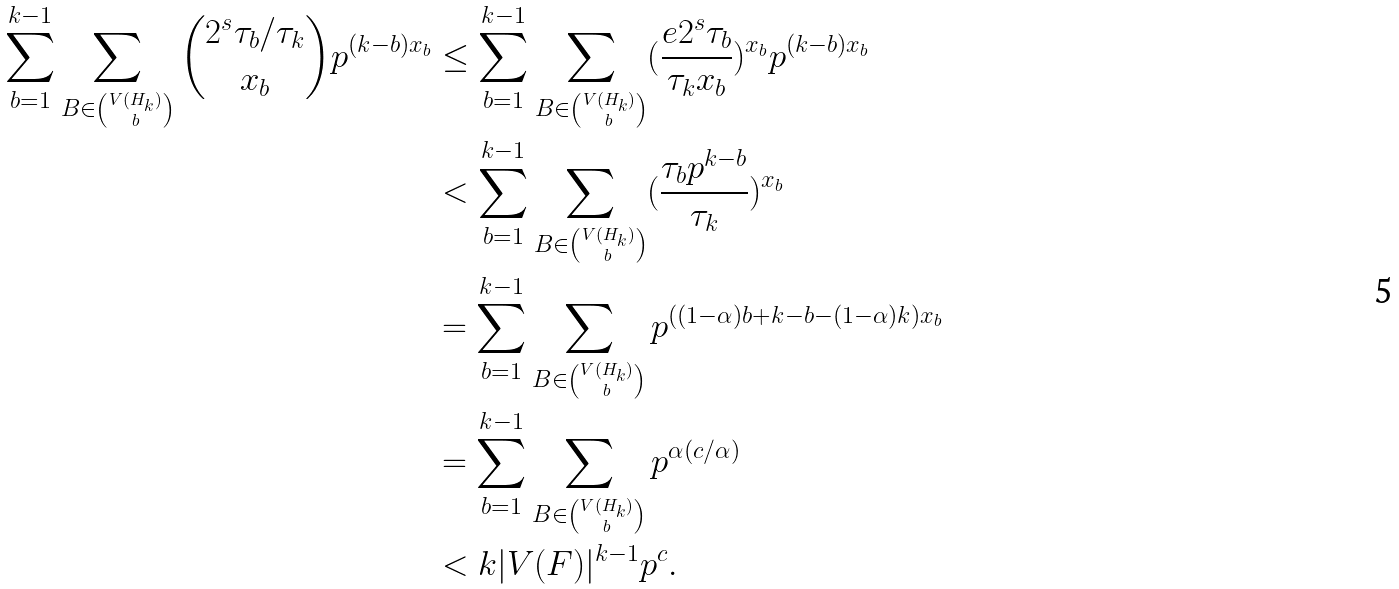<formula> <loc_0><loc_0><loc_500><loc_500>\sum _ { b = 1 } ^ { k - 1 } \sum _ { B \in \binom { V ( H _ { k } ) } { b } } \binom { 2 ^ { s } \tau _ { b } / \tau _ { k } } { x _ { b } } p ^ { ( k - b ) x _ { b } } & \leq \sum _ { b = 1 } ^ { k - 1 } \sum _ { B \in \binom { V ( H _ { k } ) } { b } } ( \frac { e 2 ^ { s } \tau _ { b } } { \tau _ { k } x _ { b } } ) ^ { x _ { b } } p ^ { ( k - b ) x _ { b } } \\ & < \sum _ { b = 1 } ^ { k - 1 } \sum _ { B \in \binom { V ( H _ { k } ) } { b } } ( \frac { \tau _ { b } p ^ { k - b } } { \tau _ { k } } ) ^ { x _ { b } } \\ & = \sum _ { b = 1 } ^ { k - 1 } \sum _ { B \in \binom { V ( H _ { k } ) } { b } } p ^ { ( ( 1 - \alpha ) b + k - b - ( 1 - \alpha ) k ) x _ { b } } \\ & = \sum _ { b = 1 } ^ { k - 1 } \sum _ { B \in \binom { V ( H _ { k } ) } { b } } p ^ { \alpha ( c / \alpha ) } \\ & < k | V ( F ) | ^ { k - 1 } p ^ { c } . \\</formula> 